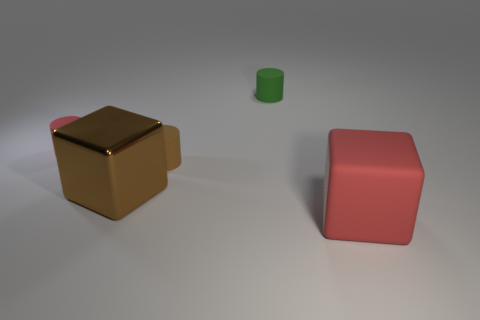Is there another tiny object that has the same shape as the small brown object?
Ensure brevity in your answer.  Yes. What is the shape of the red object in front of the red object that is behind the red block?
Your answer should be compact. Cube. The tiny thing that is in front of the tiny red rubber cylinder has what shape?
Your answer should be very brief. Cylinder. There is a large shiny block on the left side of the red cube; is it the same color as the large block that is to the right of the large brown metal thing?
Ensure brevity in your answer.  No. How many matte objects are both in front of the tiny red object and behind the big brown metallic object?
Provide a succinct answer. 1. There is a red thing that is the same material as the red block; what size is it?
Keep it short and to the point. Small. The red cube has what size?
Your answer should be very brief. Large. What is the material of the red block?
Offer a very short reply. Rubber. There is a red thing behind the metallic block; does it have the same size as the brown metallic thing?
Your answer should be very brief. No. What number of things are big things or small brown things?
Offer a very short reply. 3. 